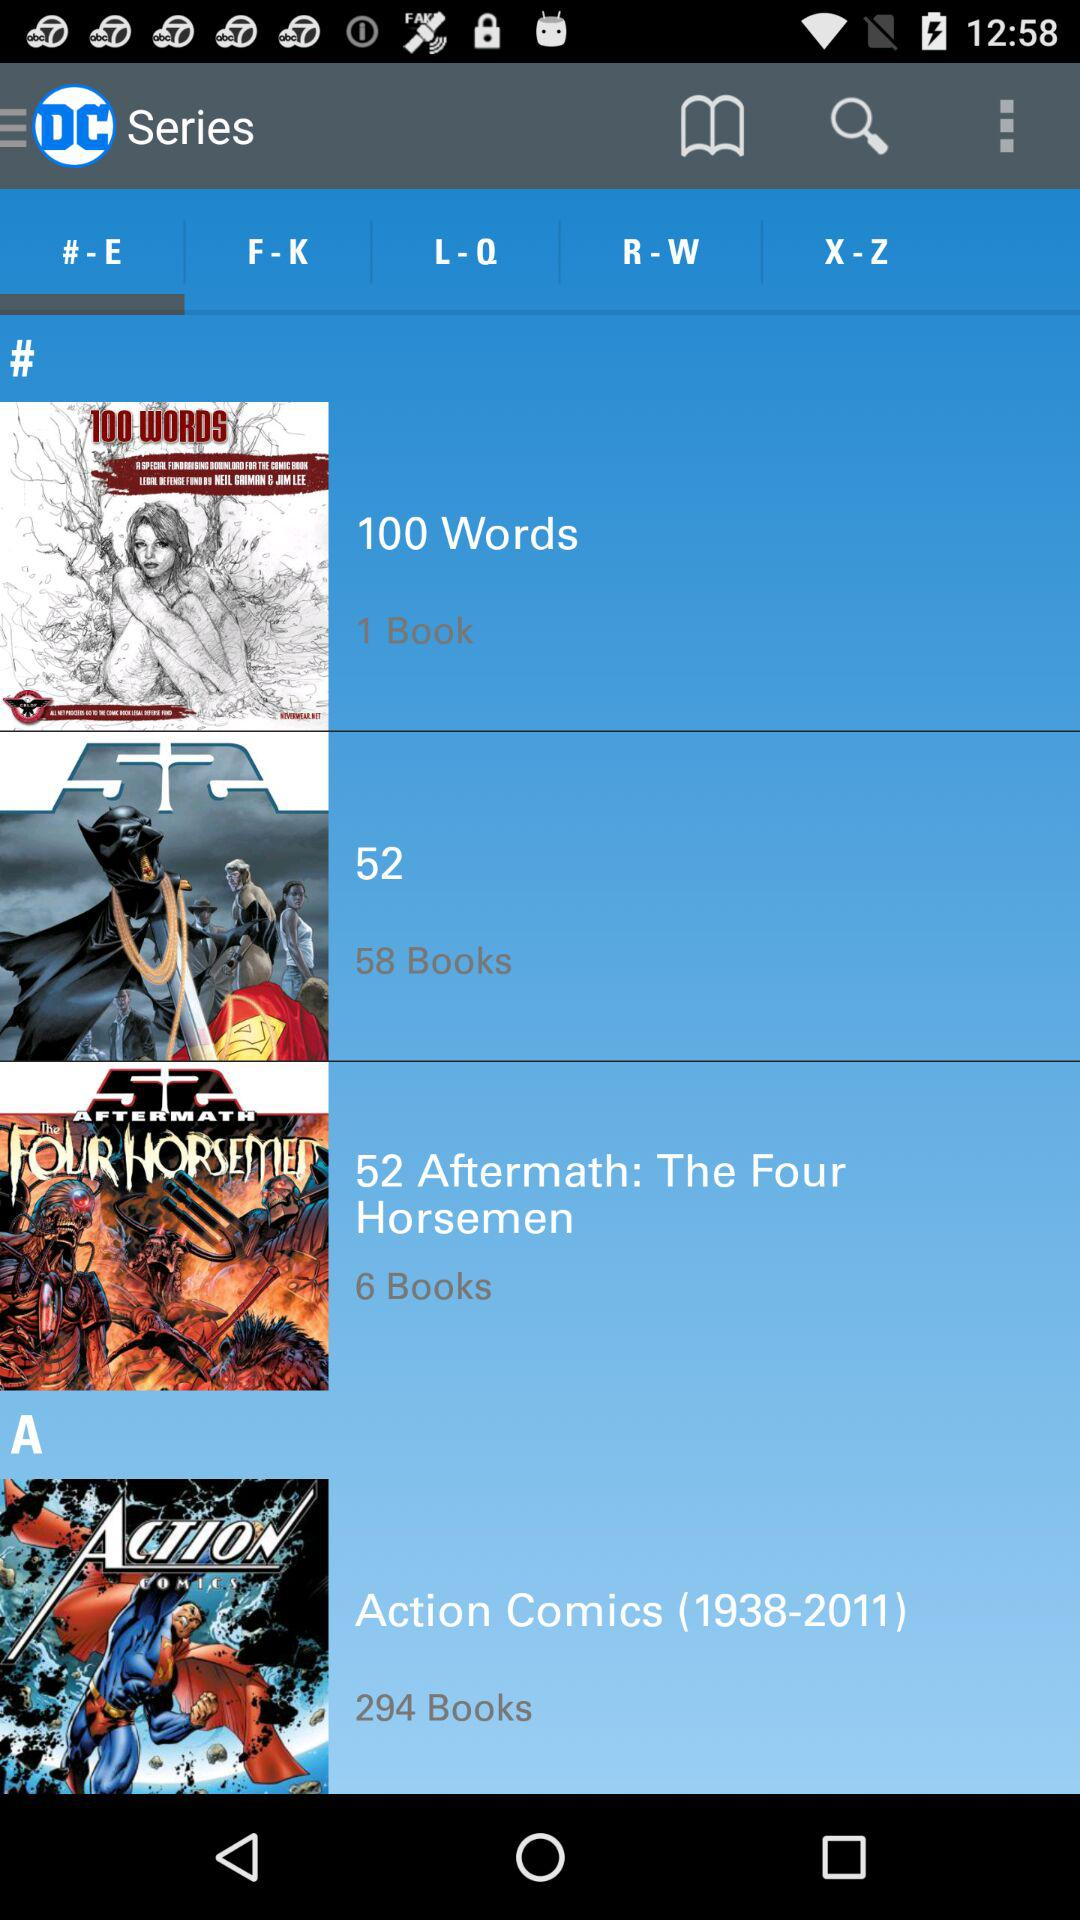How many books are there in "100 Words"? There is 1 book in "100 Words". 